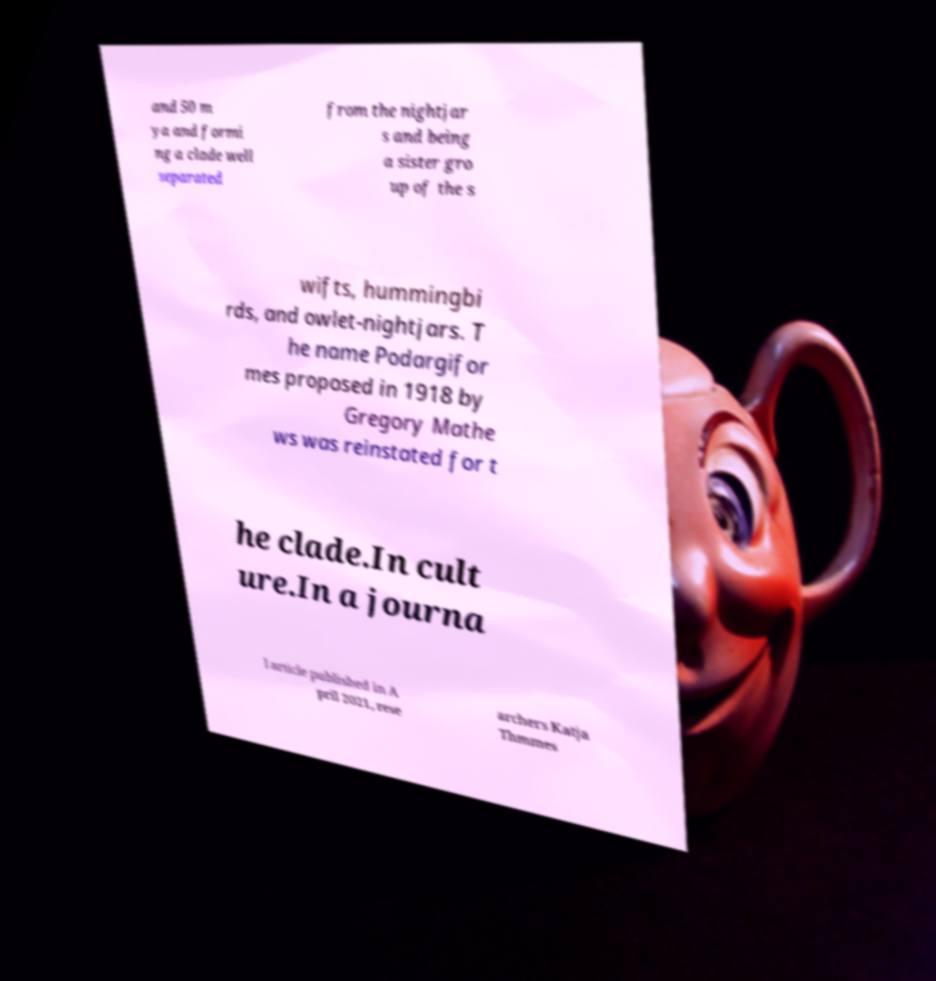Can you read and provide the text displayed in the image?This photo seems to have some interesting text. Can you extract and type it out for me? and 50 m ya and formi ng a clade well separated from the nightjar s and being a sister gro up of the s wifts, hummingbi rds, and owlet-nightjars. T he name Podargifor mes proposed in 1918 by Gregory Mathe ws was reinstated for t he clade.In cult ure.In a journa l article published in A pril 2021, rese archers Katja Thmmes 